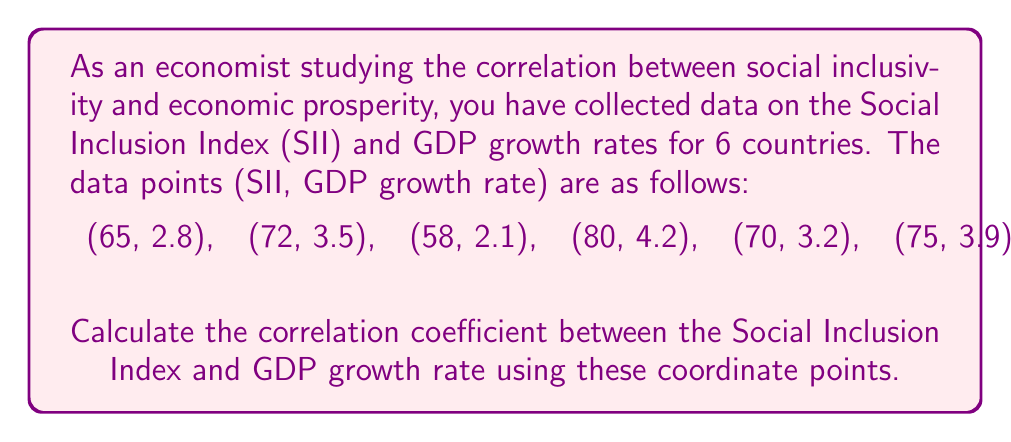Show me your answer to this math problem. To calculate the correlation coefficient, we'll use the Pearson correlation coefficient formula:

$$ r = \frac{n\sum xy - \sum x \sum y}{\sqrt{[n\sum x^2 - (\sum x)^2][n\sum y^2 - (\sum y)^2]}} $$

Where:
$x$ represents the Social Inclusion Index (SII)
$y$ represents the GDP growth rate
$n$ is the number of data points (6 in this case)

Step 1: Calculate the sums and squares:
$\sum x = 65 + 72 + 58 + 80 + 70 + 75 = 420$
$\sum y = 2.8 + 3.5 + 2.1 + 4.2 + 3.2 + 3.9 = 19.7$
$\sum xy = (65 \times 2.8) + (72 \times 3.5) + (58 \times 2.1) + (80 \times 4.2) + (70 \times 3.2) + (75 \times 3.9) = 1417.9$
$\sum x^2 = 65^2 + 72^2 + 58^2 + 80^2 + 70^2 + 75^2 = 29750$
$\sum y^2 = 2.8^2 + 3.5^2 + 2.1^2 + 4.2^2 + 3.2^2 + 3.9^2 = 66.59$

Step 2: Apply the formula:

$$ r = \frac{6(1417.9) - (420)(19.7)}{\sqrt{[6(29750) - 420^2][6(66.59) - 19.7^2]}} $$

$$ r = \frac{8507.4 - 8274}{\sqrt{(178500 - 176400)(399.54 - 388.09)}} $$

$$ r = \frac{233.4}{\sqrt{(2100)(11.45)}} $$

$$ r = \frac{233.4}{\sqrt{24045}} $$

$$ r = \frac{233.4}{155.06} $$

$$ r \approx 0.9856 $$

Step 3: Interpret the result:
The correlation coefficient of approximately 0.9856 indicates a very strong positive correlation between the Social Inclusion Index and GDP growth rate. This suggests that countries with higher social inclusion tend to have higher GDP growth rates, supporting the hypothesis that social inclusivity is positively associated with economic prosperity.
Answer: The correlation coefficient between the Social Inclusion Index and GDP growth rate is approximately 0.9856, indicating a very strong positive correlation. 